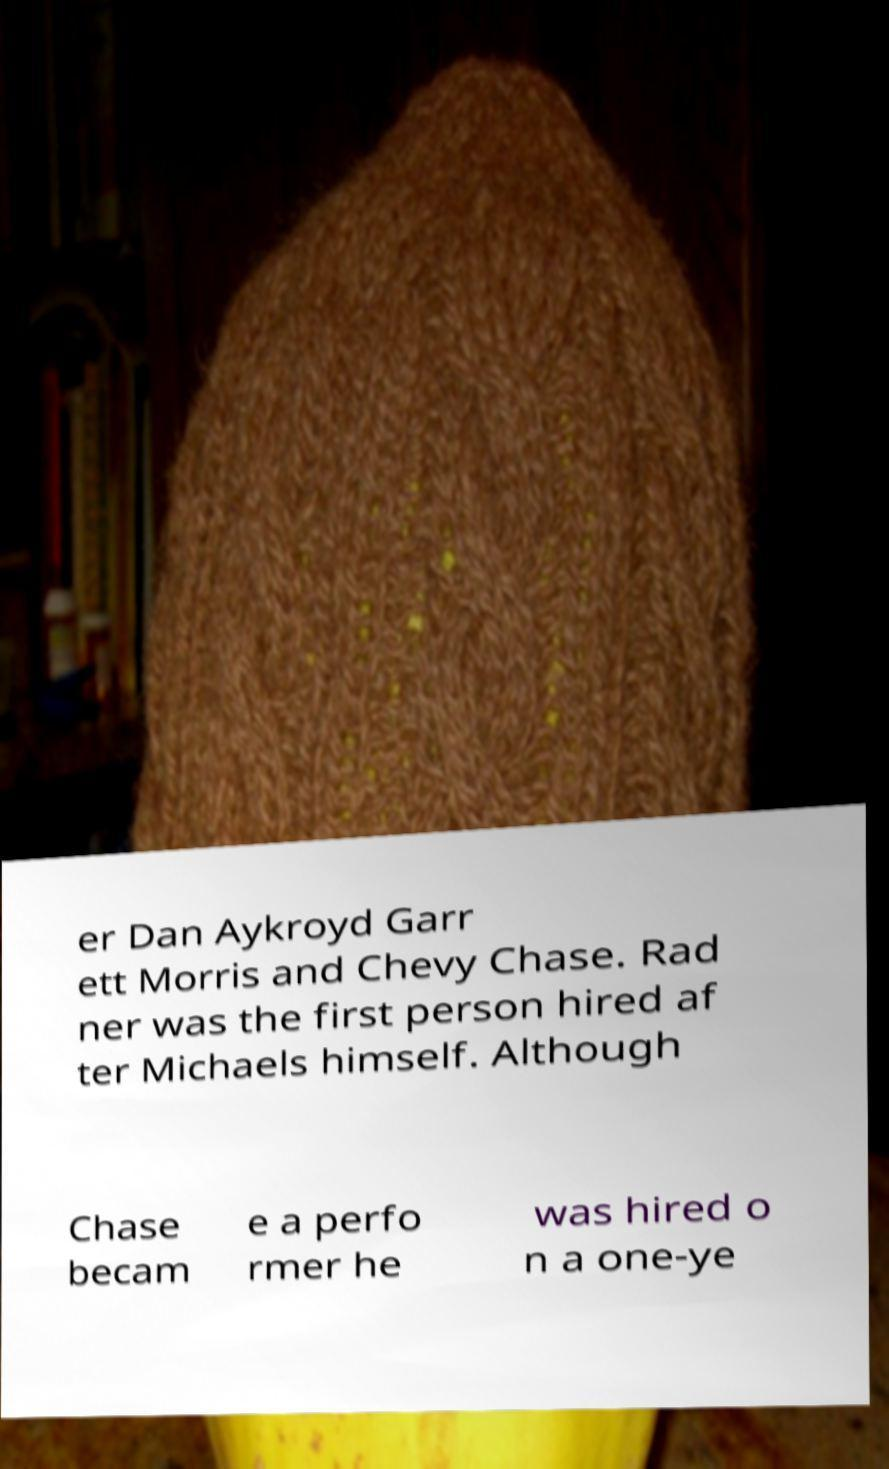Can you accurately transcribe the text from the provided image for me? er Dan Aykroyd Garr ett Morris and Chevy Chase. Rad ner was the first person hired af ter Michaels himself. Although Chase becam e a perfo rmer he was hired o n a one-ye 